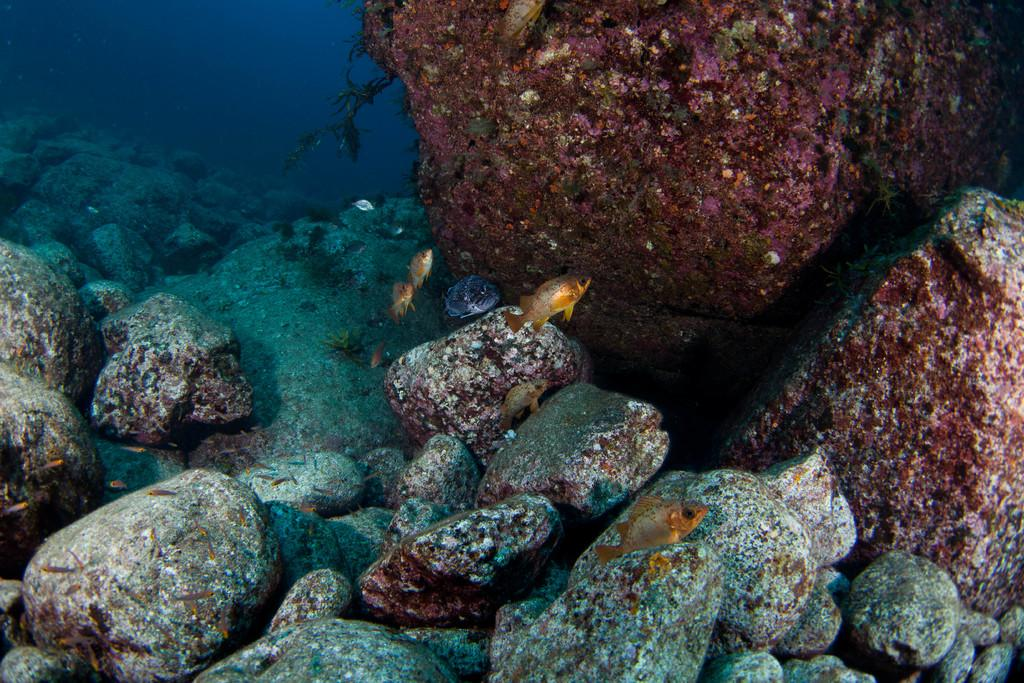Where was the image taken? The image is taken inside the water. What can be seen swimming in the water? There are small fishes in the water. What is visible at the bottom of the image? There are stones at the bottom of the image. What type of vegetation is present on the stones? There is algae on the stones on the right side of the image. Can you see a yak wearing a crown in the image? No, there is no yak or crown present in the image; it is taken underwater and features small fishes, stones, and algae. 